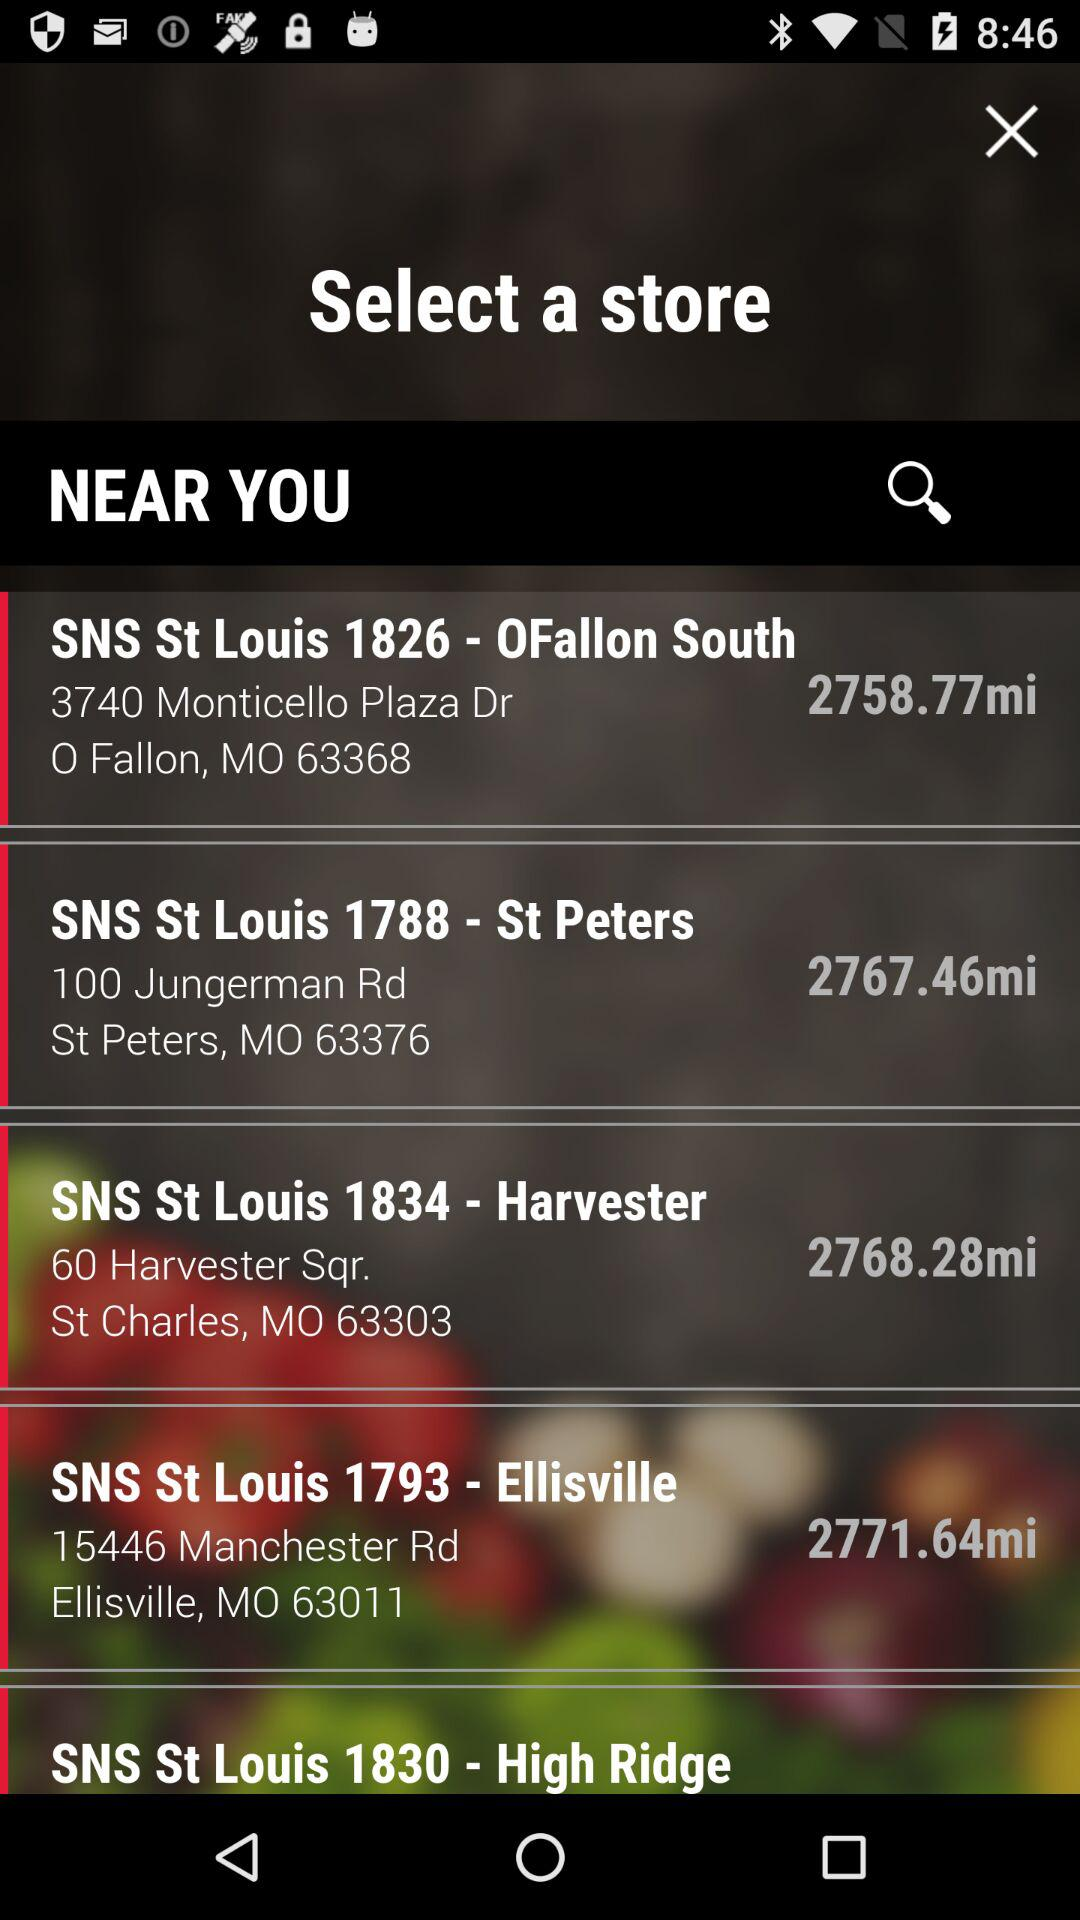Which are the nearest stores? The nearest stores are "SNS St Louis 1826 - OFallon South", "SNS St Louis 1788 - St Peters", "SNS St Louis 1834 - Harvester", "SNS St Louis 1793 - Ellisville" and "SNS St Louis 1830 - High Ridge". 